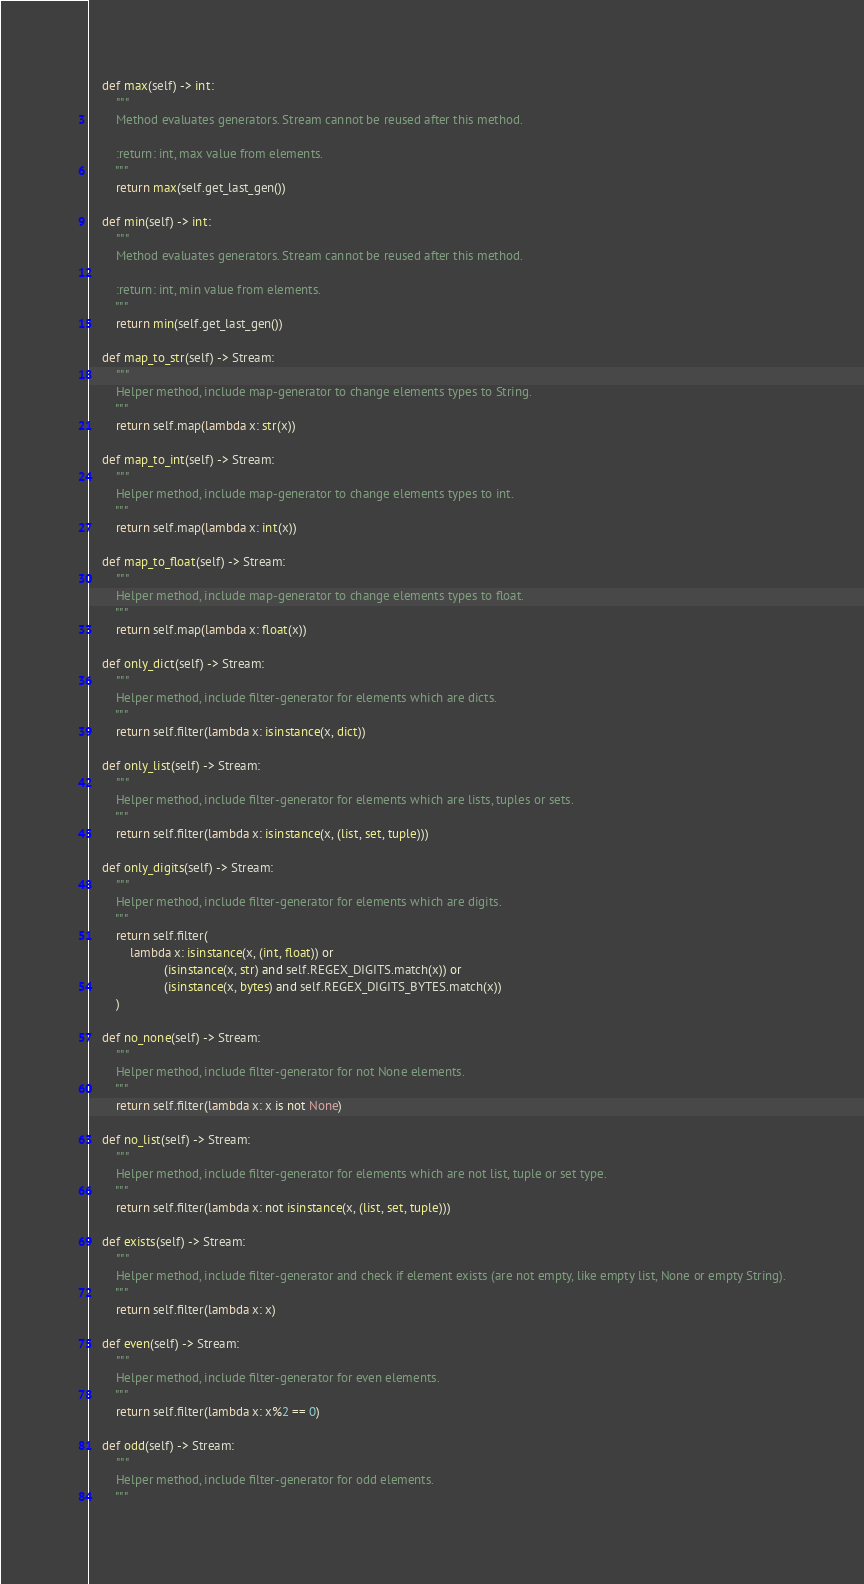<code> <loc_0><loc_0><loc_500><loc_500><_Python_>    def max(self) -> int:
        """
        Method evaluates generators. Stream cannot be reused after this method.

        :return: int, max value from elements.
        """
        return max(self.get_last_gen())

    def min(self) -> int:
        """
        Method evaluates generators. Stream cannot be reused after this method.

        :return: int, min value from elements.
        """
        return min(self.get_last_gen())

    def map_to_str(self) -> Stream:
        """
        Helper method, include map-generator to change elements types to String.
        """
        return self.map(lambda x: str(x))

    def map_to_int(self) -> Stream:
        """
        Helper method, include map-generator to change elements types to int.
        """
        return self.map(lambda x: int(x))

    def map_to_float(self) -> Stream:
        """
        Helper method, include map-generator to change elements types to float.
        """
        return self.map(lambda x: float(x))

    def only_dict(self) -> Stream:
        """
        Helper method, include filter-generator for elements which are dicts.
        """
        return self.filter(lambda x: isinstance(x, dict))

    def only_list(self) -> Stream:
        """
        Helper method, include filter-generator for elements which are lists, tuples or sets.
        """
        return self.filter(lambda x: isinstance(x, (list, set, tuple)))

    def only_digits(self) -> Stream:
        """
        Helper method, include filter-generator for elements which are digits.
        """
        return self.filter(
            lambda x: isinstance(x, (int, float)) or
                      (isinstance(x, str) and self.REGEX_DIGITS.match(x)) or
                      (isinstance(x, bytes) and self.REGEX_DIGITS_BYTES.match(x))
        )

    def no_none(self) -> Stream:
        """
        Helper method, include filter-generator for not None elements.
        """
        return self.filter(lambda x: x is not None)

    def no_list(self) -> Stream:
        """
        Helper method, include filter-generator for elements which are not list, tuple or set type.
        """
        return self.filter(lambda x: not isinstance(x, (list, set, tuple)))

    def exists(self) -> Stream:
        """
        Helper method, include filter-generator and check if element exists (are not empty, like empty list, None or empty String).
        """
        return self.filter(lambda x: x)

    def even(self) -> Stream:
        """
        Helper method, include filter-generator for even elements.
        """
        return self.filter(lambda x: x%2 == 0)

    def odd(self) -> Stream:
        """
        Helper method, include filter-generator for odd elements.
        """</code> 